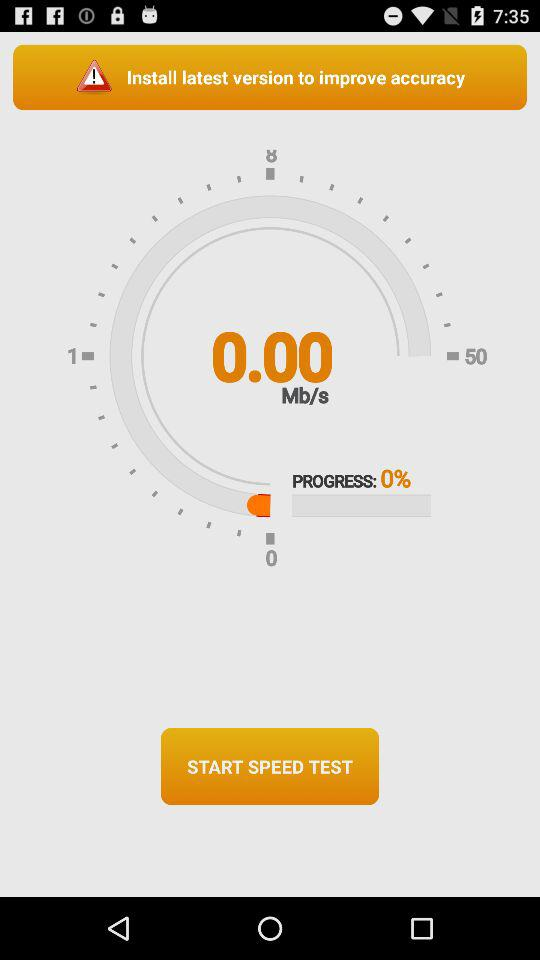What is the progress percentage of "Speed test"? The progress percentage is 0. 